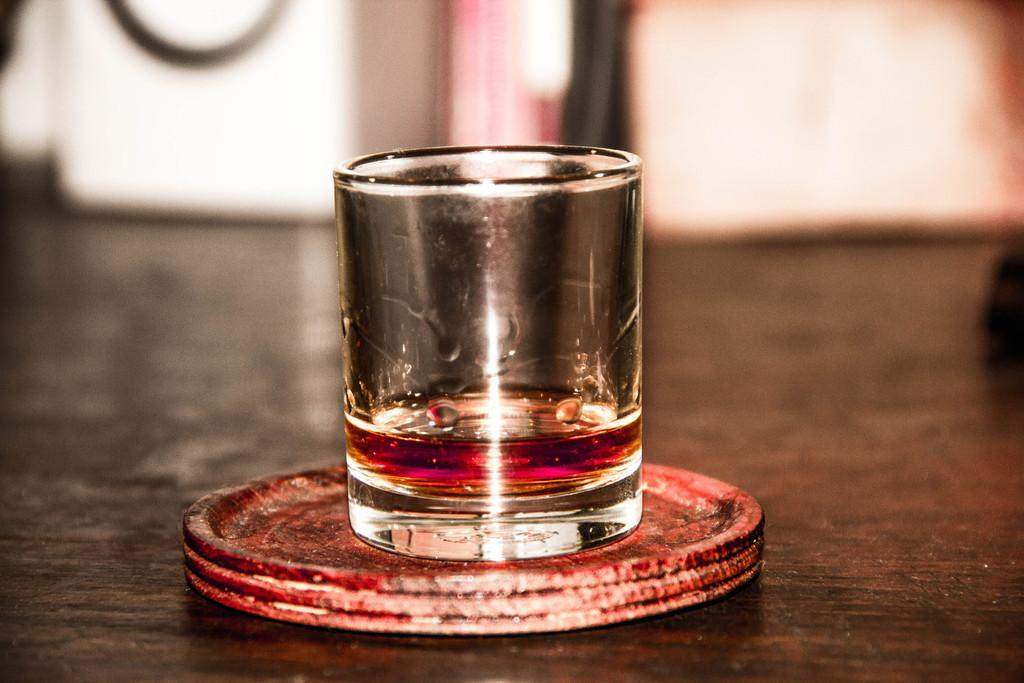What is contained in the glass in the image? There is a beverage in a glass. Where is the glass located in the image? The glass is placed on a table. What flavor of shake is being crushed in the image? There is no shake or crushing action present in the image; it only features a beverage in a glass placed on a table. 